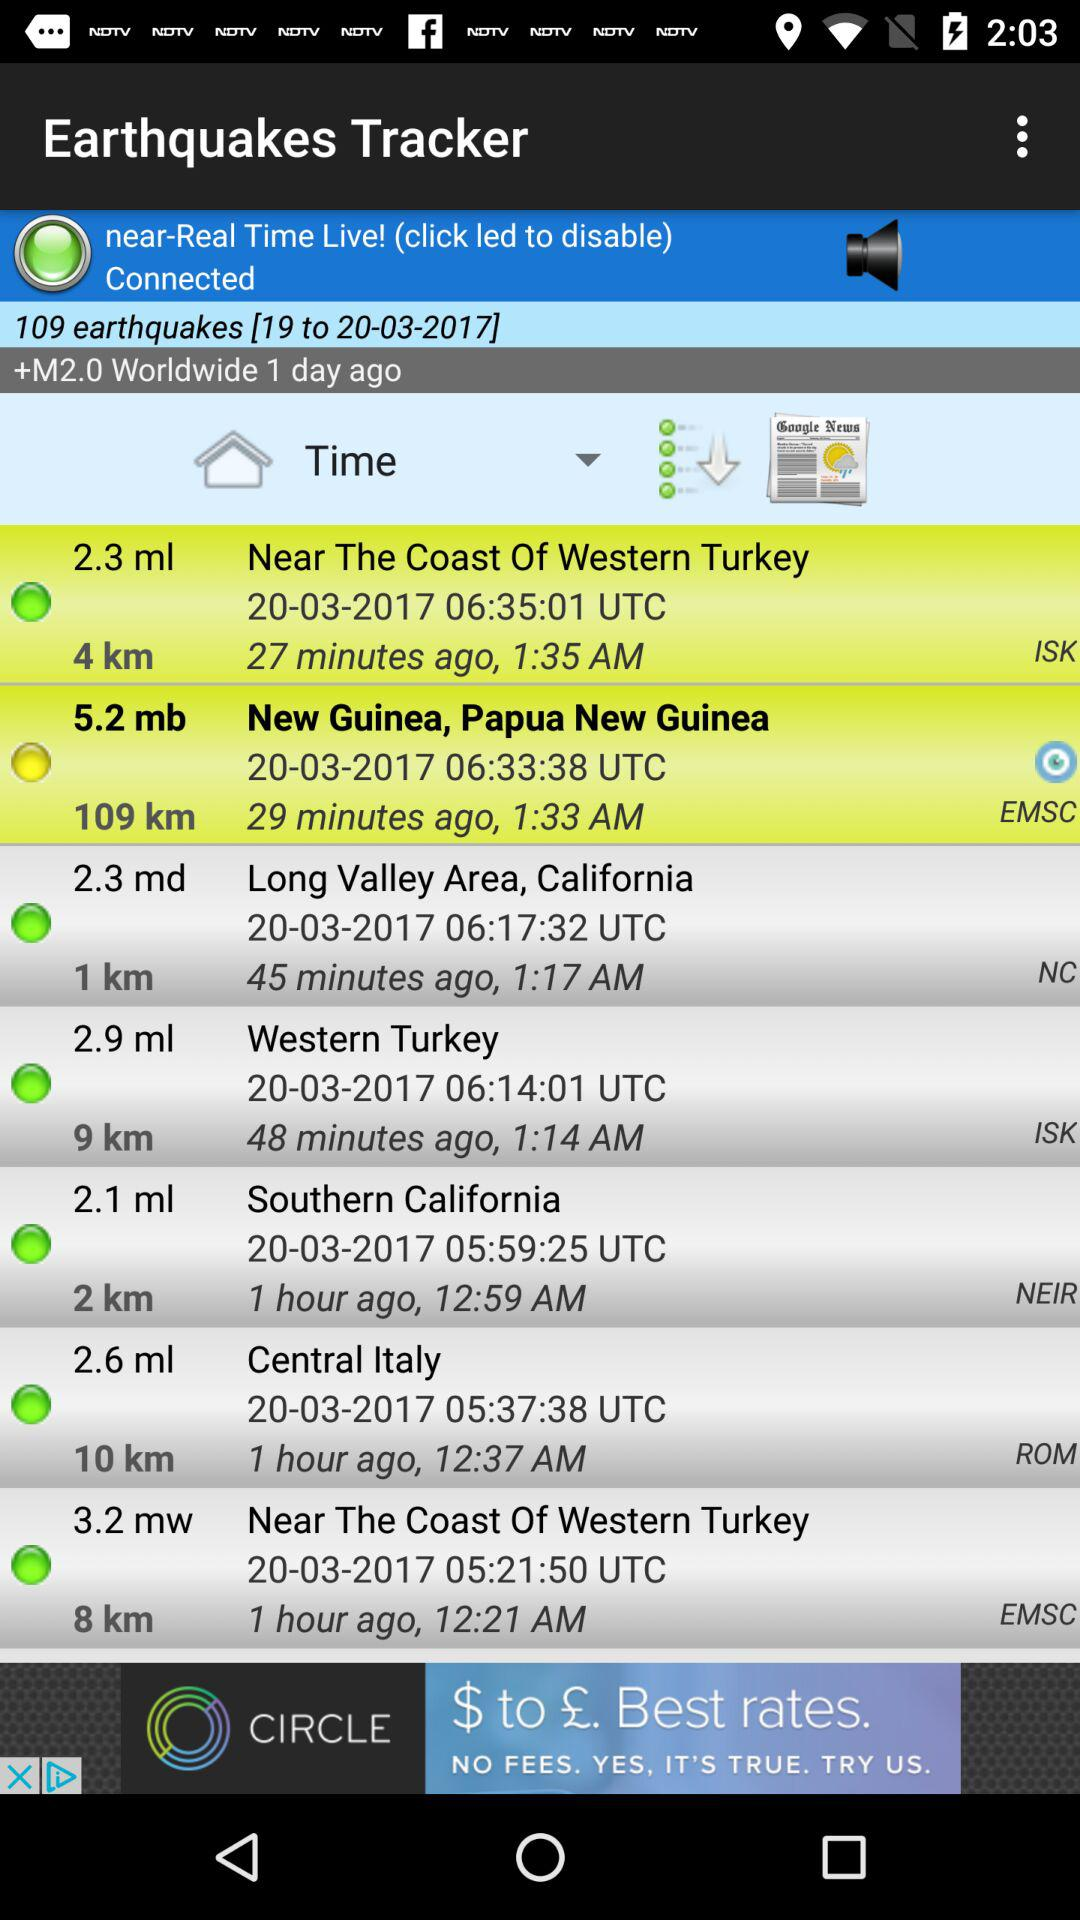Which tab is selected?
When the provided information is insufficient, respond with <no answer>. <no answer> 